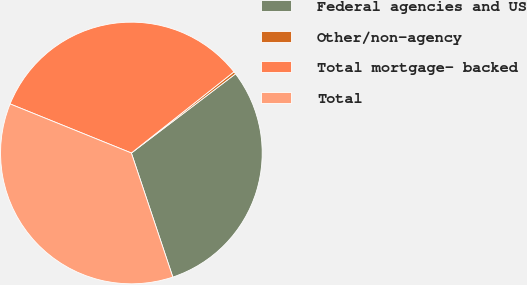Convert chart to OTSL. <chart><loc_0><loc_0><loc_500><loc_500><pie_chart><fcel>Federal agencies and US<fcel>Other/non-agency<fcel>Total mortgage- backed<fcel>Total<nl><fcel>30.21%<fcel>0.31%<fcel>33.23%<fcel>36.25%<nl></chart> 